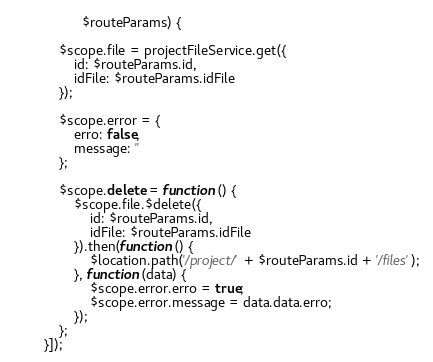Convert code to text. <code><loc_0><loc_0><loc_500><loc_500><_JavaScript_>                  $routeParams) {

            $scope.file = projectFileService.get({
                id: $routeParams.id,
                idFile: $routeParams.idFile
            });

            $scope.error = {
                erro: false,
                message: ''
            };

            $scope.delete = function () {
                $scope.file.$delete({
                    id: $routeParams.id,
                    idFile: $routeParams.idFile
                }).then(function () {
                    $location.path('/project/' + $routeParams.id + '/files');
                }, function (data) {
                    $scope.error.erro = true;
                    $scope.error.message = data.data.erro;
                });
            };
        }]);</code> 